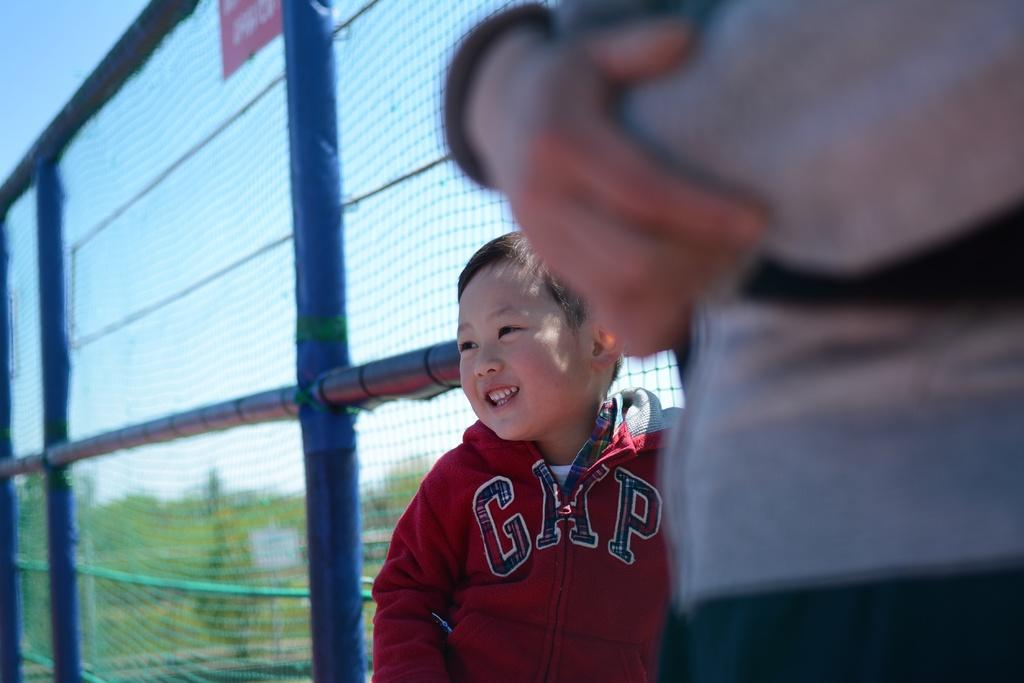Provide a one-sentence caption for the provided image. a little boy wearing a jacket that says 'gap'. 